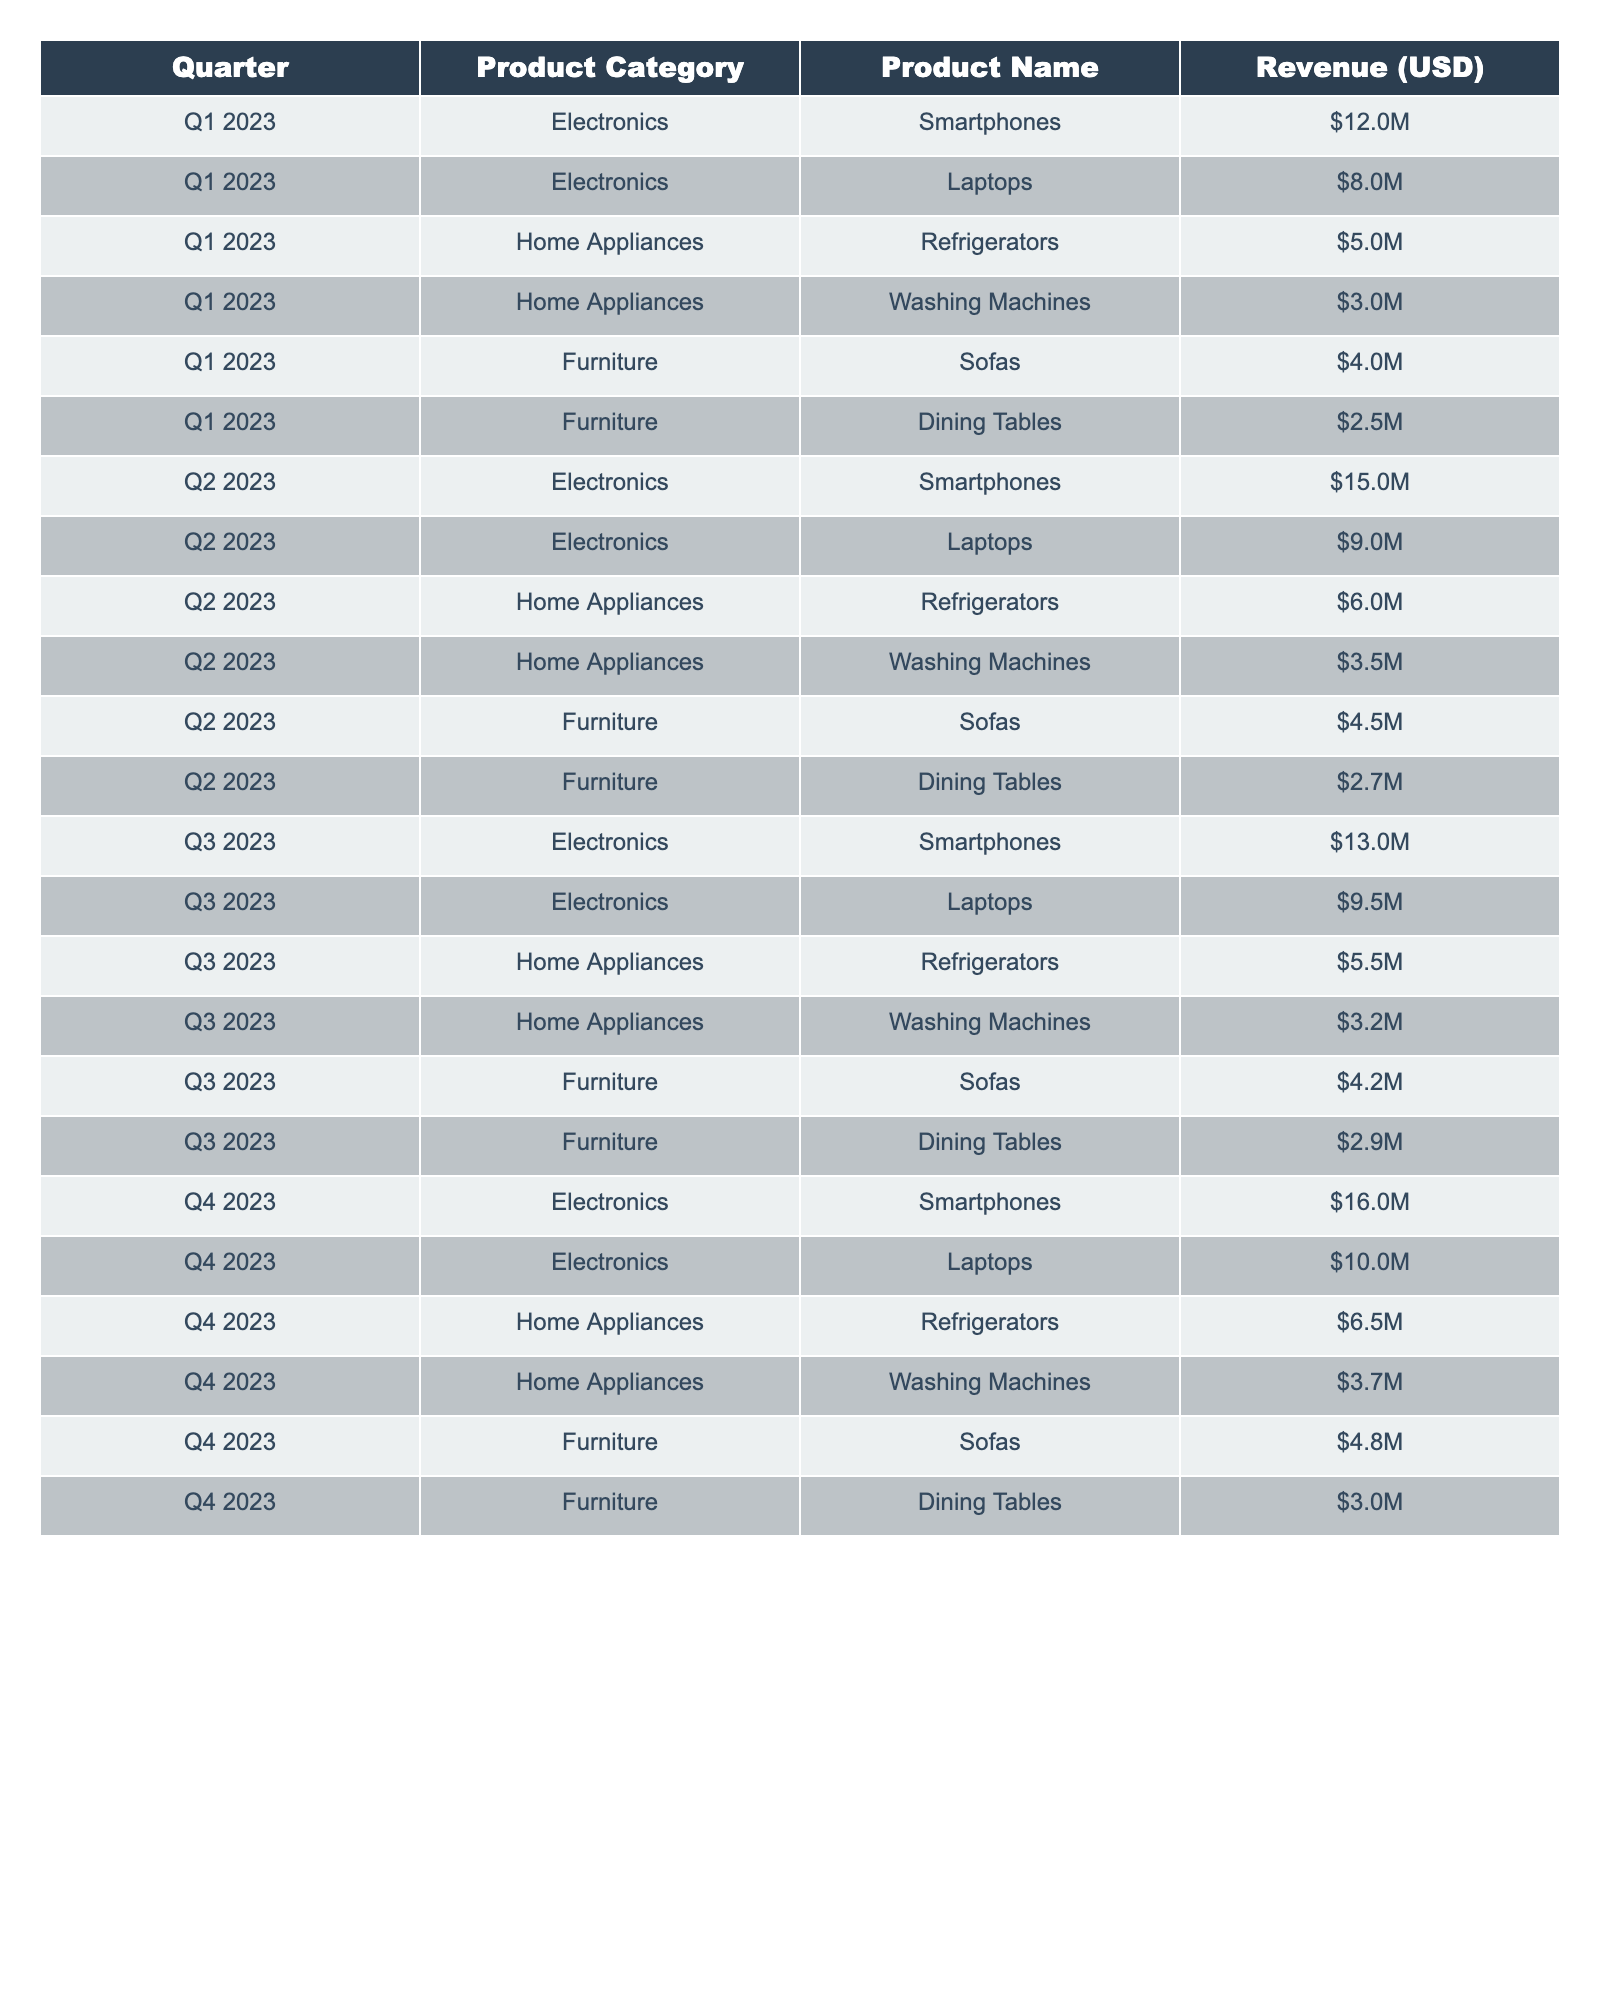What was the total revenue from Electronics in Q1 2023? The revenue from Electronics in Q1 2023 includes Smartphones ($12M) and Laptops ($8M). Adding these together gives $12M + $8M = $20M.
Answer: $20M How much revenue did Home Appliances generate in Q2 2023? In Q2 2023, Home Appliances revenue comes from Refrigerators ($6M) and Washing Machines ($3.5M). The total revenue is $6M + $3.5M = $9.5M.
Answer: $9.5M Did the revenue from Sofas increase from Q1 to Q4 2023? In Q1 2023, Sofas generated $4M, while in Q4 2023, they generated $4.8M. Since $4.8M is greater than $4M, the revenue did increase.
Answer: Yes What was the average revenue of all Furniture products across the four quarters? The revenue for Furniture over the four quarters is: Q1 ($6.25M), Q2 ($7.2M), Q3 ($7.1M), Q4 ($7.8M). The total is $6.25M + $7.2M + $7.1M + $7.8M = $28.35M. Dividing by 4 gives an average of $28.35M / 4 = $7.0875M.
Answer: $7.09M Which product category had the highest revenue in Q3 2023? In Q3 2023, the revenue from Electronics ($22M) is higher than Home Appliances ($8.7M) and Furniture ($7.1M). Since $22M is the greatest, Electronics had the highest revenue.
Answer: Electronics What was the revenue growth percentage for Smartphones from Q1 to Q4 2023? The revenue from Smartphones increased from $12M in Q1 to $16M in Q4. The growth is calculated as ((16 - 12) / 12) * 100 = (4 / 12) * 100 = 33.33%.
Answer: 33.33% What is the total revenue for Home Appliances across all quarters? The total revenue for Home Appliances is: Q1 ($8M), Q2 ($9.5M), Q3 ($8.7M), and Q4 ($10.2M). Adding these gives $8M + $9.5M + $8.7M + $10.2M = $36.4M.
Answer: $36.4M Was the total revenue from Laptops in 2023 greater than $30 million? The revenue for Laptops across the quarters is: Q1 ($8M), Q2 ($9M), Q3 ($9.5M), and Q4 ($10M). Adding these, we get $8M + $9M + $9.5M + $10M = $36.5M, which is indeed greater than $30M.
Answer: Yes What is the percentage of total revenue from the Furniture category in Q2 2023 compared to total revenue across all categories in that quarter? The total revenue in Q2 2023 is $51.2M (Electronics: $24M, Home Appliances: $9.5M, Furniture: $7.2M). The Furniture total is $7.2M, so the percentage is ($7.2M / $51.2M) * 100 = 14.06%.
Answer: 14.06% What was the total revenue across all categories in Q1 2023? The revenue for Q1 2023 includes: Electronics ($20M), Home Appliances ($8M), and Furniture ($6.25M). The total is $20M + $8M + $6.25M = $34.25M.
Answer: $34.25M 